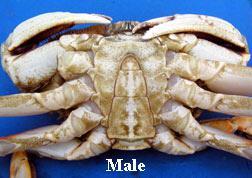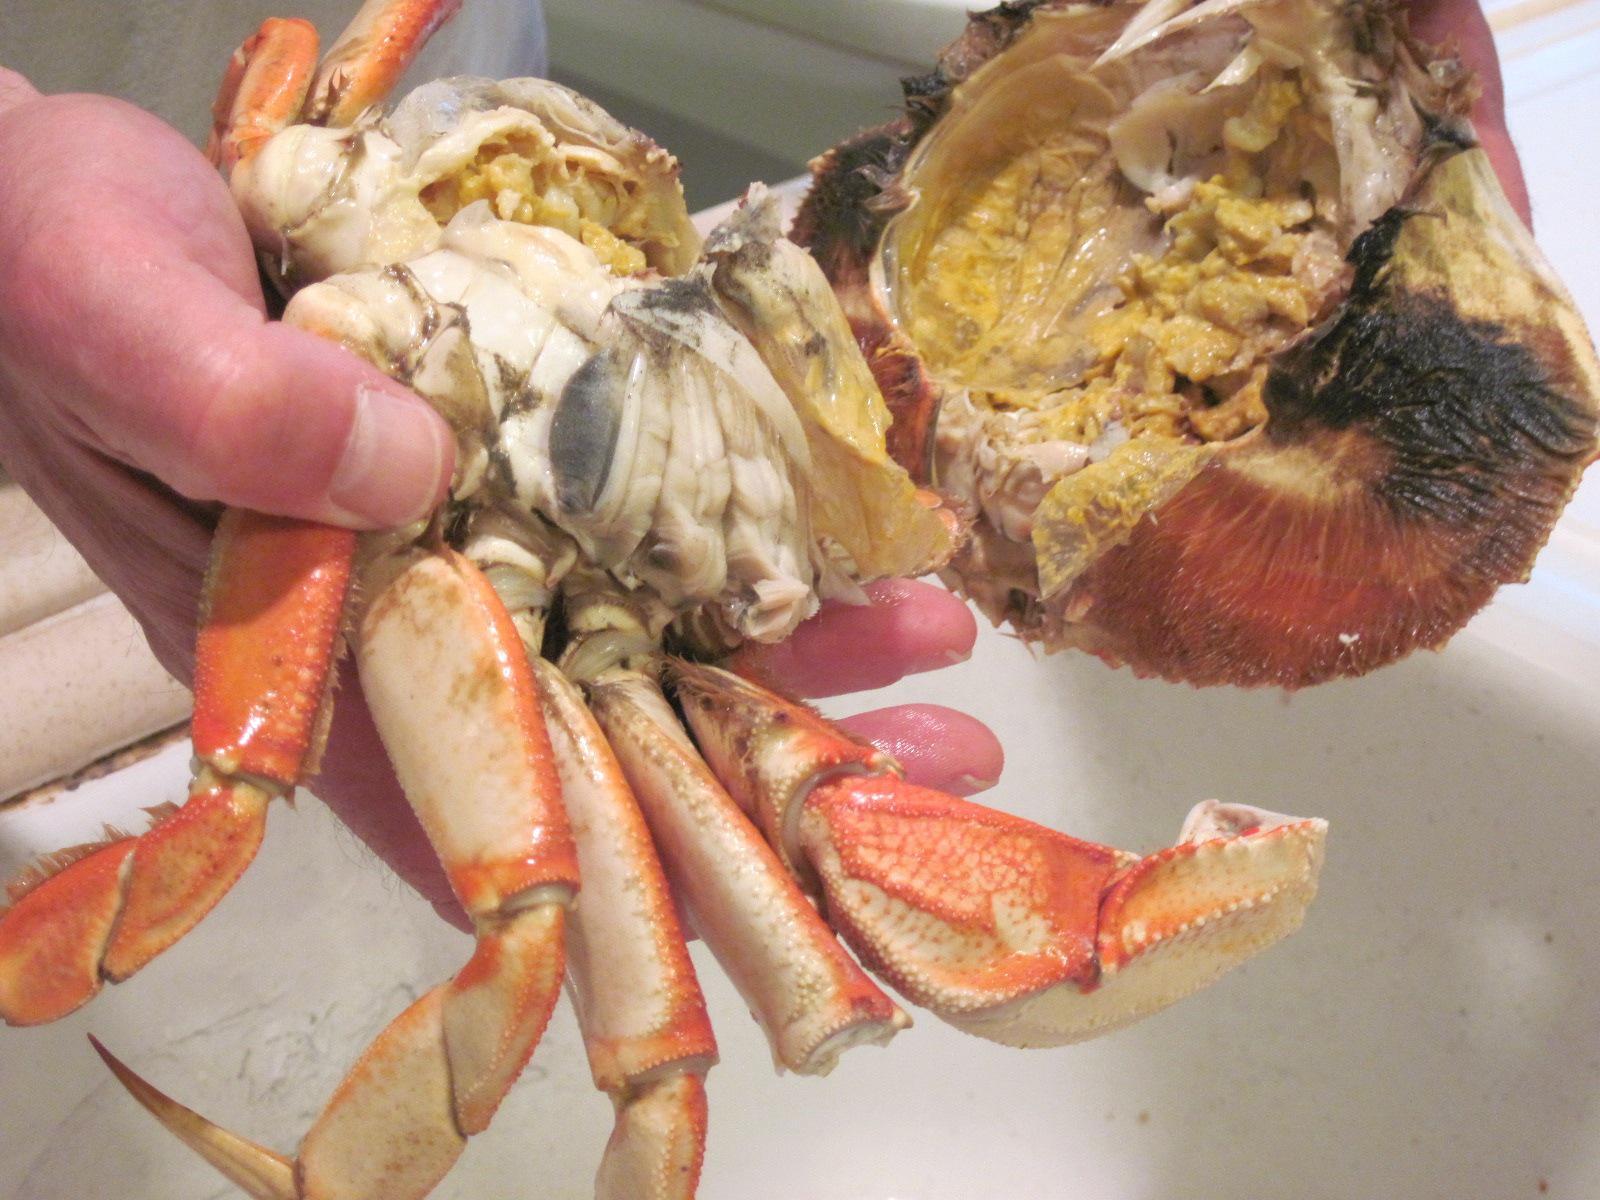The first image is the image on the left, the second image is the image on the right. Evaluate the accuracy of this statement regarding the images: "there are three crabs in the image pair". Is it true? Answer yes or no. No. 